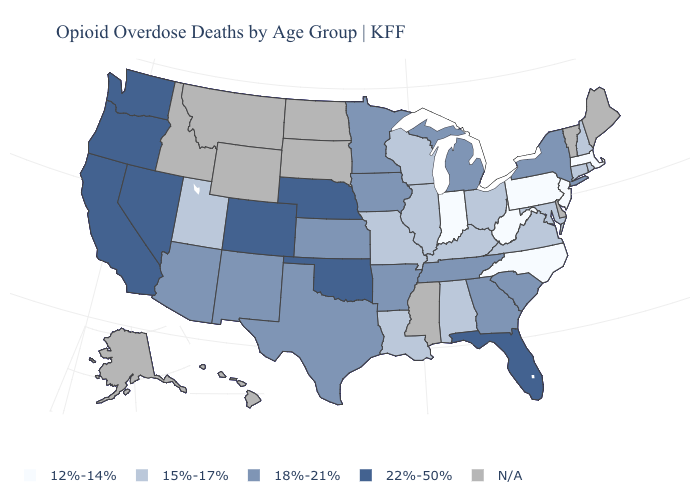What is the value of New Hampshire?
Short answer required. 15%-17%. Does the first symbol in the legend represent the smallest category?
Short answer required. Yes. Does Colorado have the highest value in the USA?
Quick response, please. Yes. Which states hav the highest value in the West?
Write a very short answer. California, Colorado, Nevada, Oregon, Washington. Does the map have missing data?
Answer briefly. Yes. Does Connecticut have the lowest value in the Northeast?
Be succinct. No. Name the states that have a value in the range 22%-50%?
Write a very short answer. California, Colorado, Florida, Nebraska, Nevada, Oklahoma, Oregon, Washington. Among the states that border Kentucky , which have the highest value?
Keep it brief. Tennessee. Name the states that have a value in the range N/A?
Concise answer only. Alaska, Delaware, Hawaii, Idaho, Maine, Mississippi, Montana, North Dakota, South Dakota, Vermont, Wyoming. Name the states that have a value in the range 15%-17%?
Give a very brief answer. Alabama, Connecticut, Illinois, Kentucky, Louisiana, Maryland, Missouri, New Hampshire, Ohio, Rhode Island, Utah, Virginia, Wisconsin. Among the states that border Colorado , which have the highest value?
Write a very short answer. Nebraska, Oklahoma. Does the first symbol in the legend represent the smallest category?
Keep it brief. Yes. Does the map have missing data?
Short answer required. Yes. What is the lowest value in the USA?
Concise answer only. 12%-14%. 